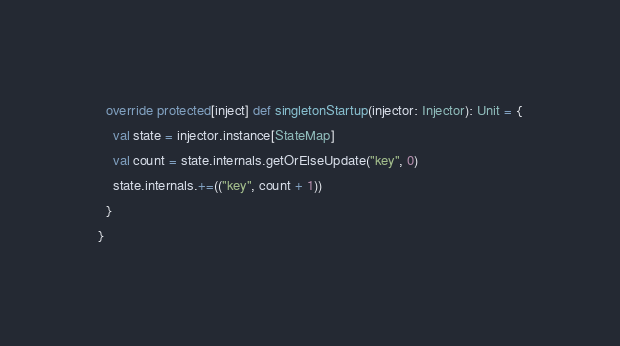Convert code to text. <code><loc_0><loc_0><loc_500><loc_500><_Scala_>  override protected[inject] def singletonStartup(injector: Injector): Unit = {
    val state = injector.instance[StateMap]
    val count = state.internals.getOrElseUpdate("key", 0)
    state.internals.+=(("key", count + 1))
  }
}
</code> 